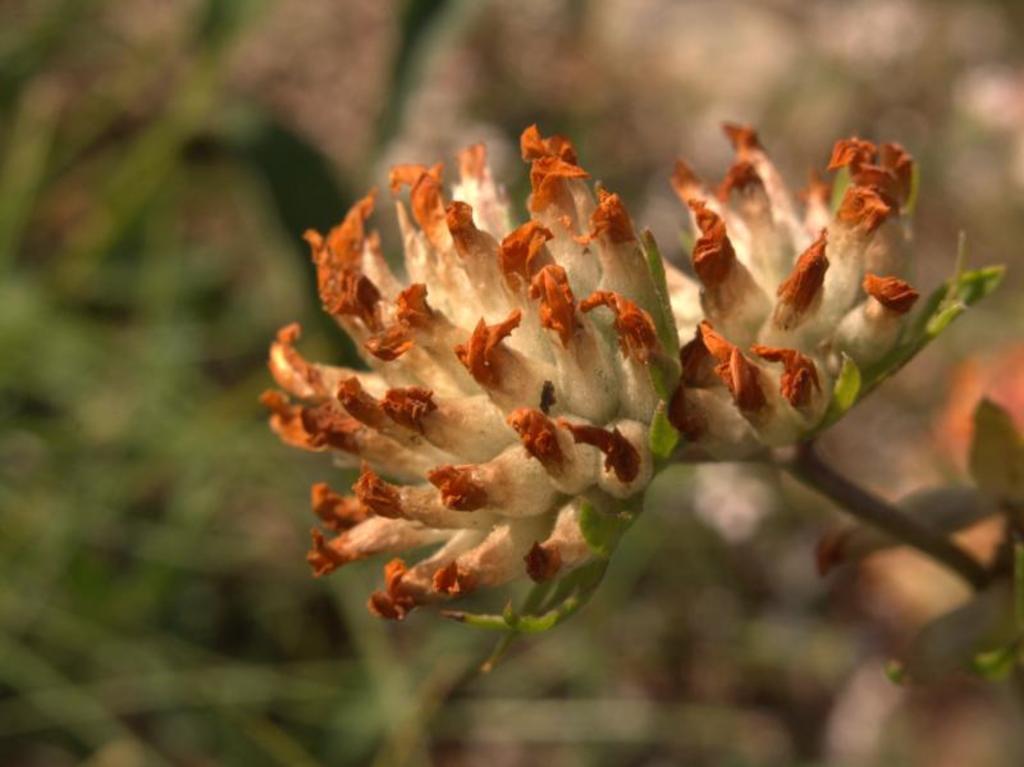Can you describe this image briefly? In this image there is a flower in the middle. In the background it looks blurry. 